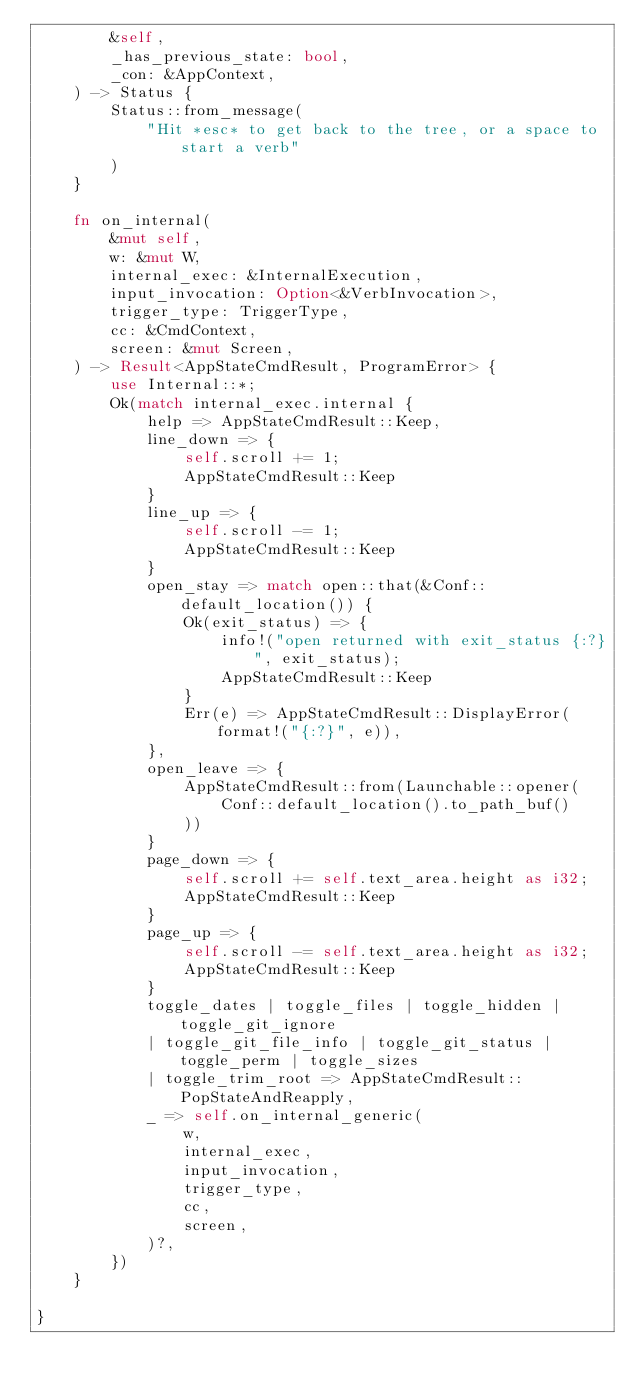Convert code to text. <code><loc_0><loc_0><loc_500><loc_500><_Rust_>        &self,
        _has_previous_state: bool,
        _con: &AppContext,
    ) -> Status {
        Status::from_message(
            "Hit *esc* to get back to the tree, or a space to start a verb"
        )
    }

    fn on_internal(
        &mut self,
        w: &mut W,
        internal_exec: &InternalExecution,
        input_invocation: Option<&VerbInvocation>,
        trigger_type: TriggerType,
        cc: &CmdContext,
        screen: &mut Screen,
    ) -> Result<AppStateCmdResult, ProgramError> {
        use Internal::*;
        Ok(match internal_exec.internal {
            help => AppStateCmdResult::Keep,
            line_down => {
                self.scroll += 1;
                AppStateCmdResult::Keep
            }
            line_up => {
                self.scroll -= 1;
                AppStateCmdResult::Keep
            }
            open_stay => match open::that(&Conf::default_location()) {
                Ok(exit_status) => {
                    info!("open returned with exit_status {:?}", exit_status);
                    AppStateCmdResult::Keep
                }
                Err(e) => AppStateCmdResult::DisplayError(format!("{:?}", e)),
            },
            open_leave => {
                AppStateCmdResult::from(Launchable::opener(
                    Conf::default_location().to_path_buf()
                ))
            }
            page_down => {
                self.scroll += self.text_area.height as i32;
                AppStateCmdResult::Keep
            }
            page_up => {
                self.scroll -= self.text_area.height as i32;
                AppStateCmdResult::Keep
            }
            toggle_dates | toggle_files | toggle_hidden | toggle_git_ignore
            | toggle_git_file_info | toggle_git_status | toggle_perm | toggle_sizes
            | toggle_trim_root => AppStateCmdResult::PopStateAndReapply,
            _ => self.on_internal_generic(
                w,
                internal_exec,
                input_invocation,
                trigger_type,
                cc,
                screen,
            )?,
        })
    }

}
</code> 